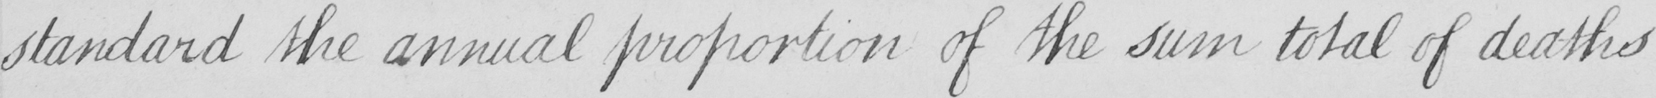What is written in this line of handwriting? standard the annual proportion of the sum total of deaths 